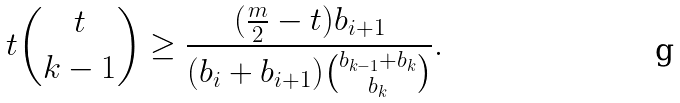<formula> <loc_0><loc_0><loc_500><loc_500>t \binom { t } { k - 1 } \geq \frac { ( \frac { m } { 2 } - t ) b _ { i + 1 } } { ( b _ { i } + b _ { i + 1 } ) \binom { b _ { k - 1 } + b _ { k } } { b _ { k } } } .</formula> 